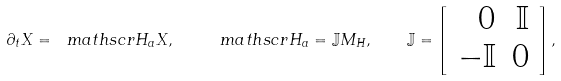Convert formula to latex. <formula><loc_0><loc_0><loc_500><loc_500>\partial _ { t } X = \ m a t h s c r { H } _ { a } X , \quad \ m a t h s c r { H } _ { a } = \mathbb { J } M _ { H } , \quad \mathbb { J } = \left [ \begin{array} { r r } 0 & \mathbb { I } \\ - \mathbb { I } & 0 \end{array} \right ] ,</formula> 